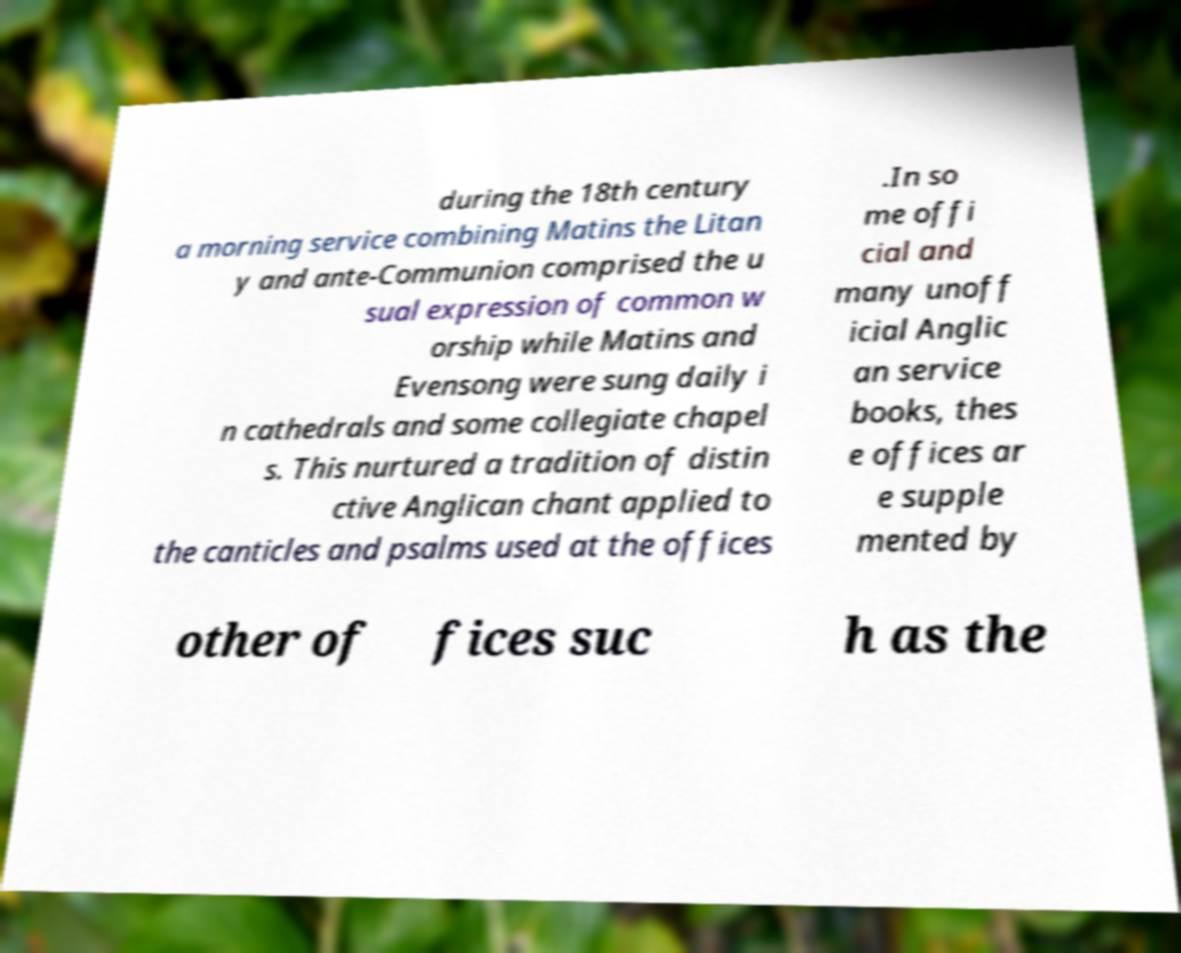Can you read and provide the text displayed in the image?This photo seems to have some interesting text. Can you extract and type it out for me? during the 18th century a morning service combining Matins the Litan y and ante-Communion comprised the u sual expression of common w orship while Matins and Evensong were sung daily i n cathedrals and some collegiate chapel s. This nurtured a tradition of distin ctive Anglican chant applied to the canticles and psalms used at the offices .In so me offi cial and many unoff icial Anglic an service books, thes e offices ar e supple mented by other of fices suc h as the 